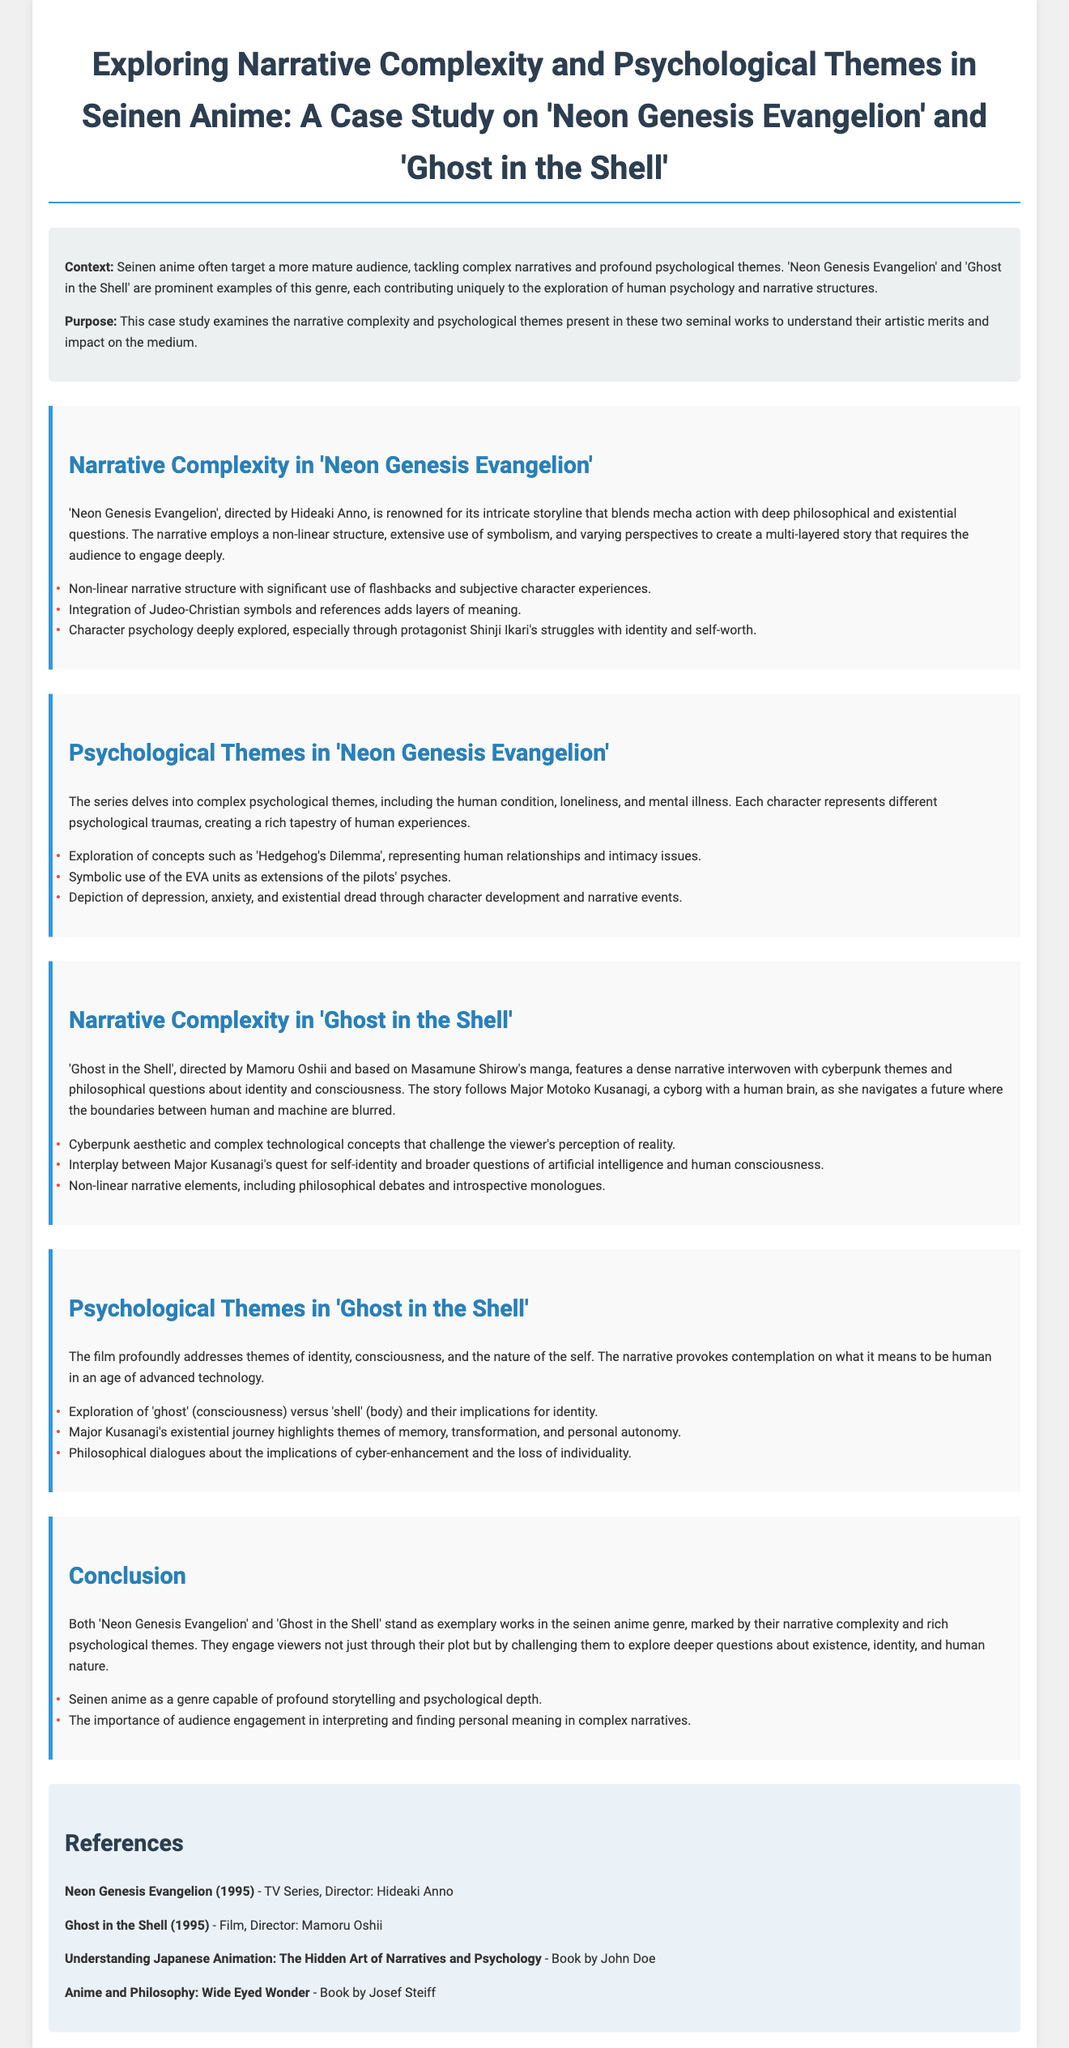What are the names of the two anime analyzed in the case study? The case study focuses on "Neon Genesis Evangelion" and "Ghost in the Shell".
Answer: "Neon Genesis Evangelion" and "Ghost in the Shell" Who directed "Neon Genesis Evangelion"? The director of "Neon Genesis Evangelion" is Hideaki Anno.
Answer: Hideaki Anno What psychological concept is represented by the "Hedgehog's Dilemma"? It represents human relationships and intimacy issues in "Neon Genesis Evangelion".
Answer: Human relationships and intimacy issues What is the primary theme explored in "Ghost in the Shell"? The film addresses themes of identity, consciousness, and the nature of the self.
Answer: Identity, consciousness, and the nature of the self What narrative structure is utilized in "Neon Genesis Evangelion"? It employs a non-linear structure with significant use of flashbacks.
Answer: Non-linear structure What do the EVA units symbolize in the narrative? They serve as extensions of the pilots' psyches in "Neon Genesis Evangelion".
Answer: Extensions of the pilots' psyches Which character's quest for self-identity drives the narrative in "Ghost in the Shell"? The story follows Major Motoko Kusanagi in her quest for self-identity.
Answer: Major Motoko Kusanagi How many references are listed in the document? There are four references mentioned in the case study.
Answer: Four What is the conclusion about the significance of Seinen anime according to the study? Seinen anime is capable of profound storytelling and psychological depth.
Answer: Profound storytelling and psychological depth 